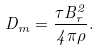<formula> <loc_0><loc_0><loc_500><loc_500>D _ { m } = \frac { \tau B _ { r } ^ { 2 } } { 4 \pi \rho } .</formula> 